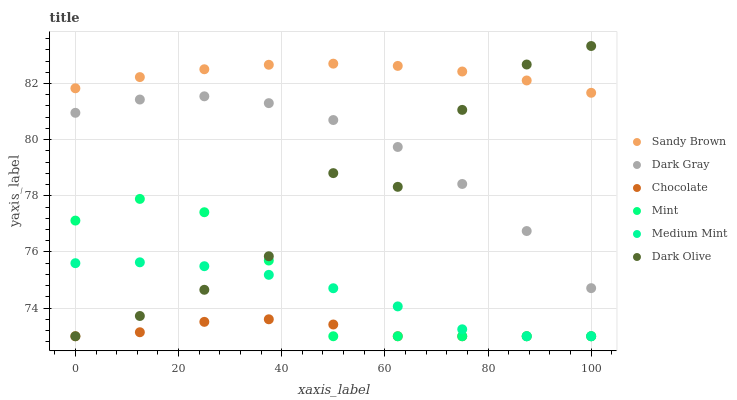Does Chocolate have the minimum area under the curve?
Answer yes or no. Yes. Does Sandy Brown have the maximum area under the curve?
Answer yes or no. Yes. Does Dark Olive have the minimum area under the curve?
Answer yes or no. No. Does Dark Olive have the maximum area under the curve?
Answer yes or no. No. Is Sandy Brown the smoothest?
Answer yes or no. Yes. Is Dark Olive the roughest?
Answer yes or no. Yes. Is Dark Olive the smoothest?
Answer yes or no. No. Is Sandy Brown the roughest?
Answer yes or no. No. Does Medium Mint have the lowest value?
Answer yes or no. Yes. Does Sandy Brown have the lowest value?
Answer yes or no. No. Does Dark Olive have the highest value?
Answer yes or no. Yes. Does Sandy Brown have the highest value?
Answer yes or no. No. Is Dark Gray less than Sandy Brown?
Answer yes or no. Yes. Is Sandy Brown greater than Dark Gray?
Answer yes or no. Yes. Does Dark Gray intersect Dark Olive?
Answer yes or no. Yes. Is Dark Gray less than Dark Olive?
Answer yes or no. No. Is Dark Gray greater than Dark Olive?
Answer yes or no. No. Does Dark Gray intersect Sandy Brown?
Answer yes or no. No. 